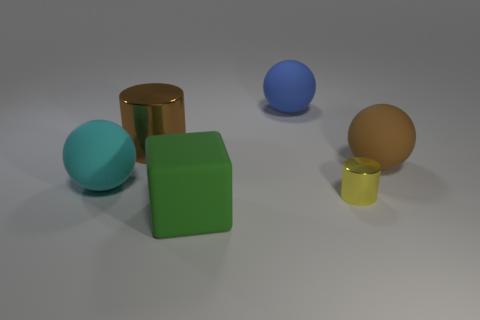What is the material of the big brown cylinder?
Your answer should be very brief. Metal. There is a large rubber thing right of the metallic cylinder in front of the brown sphere; what is its color?
Offer a terse response. Brown. Are there fewer large balls in front of the green cube than big rubber spheres right of the small cylinder?
Keep it short and to the point. Yes. Is the size of the blue ball the same as the rubber object in front of the cyan rubber ball?
Provide a short and direct response. Yes. What shape is the object that is in front of the brown rubber sphere and left of the large green object?
Give a very brief answer. Sphere. There is a yellow cylinder that is the same material as the brown cylinder; what is its size?
Provide a short and direct response. Small. How many large shiny cylinders are to the right of the blue thing behind the big brown cylinder?
Provide a short and direct response. 0. Do the large brown object that is in front of the big metallic thing and the small yellow cylinder have the same material?
Keep it short and to the point. No. How big is the metal thing to the left of the green thing on the right side of the large cyan thing?
Make the answer very short. Large. What is the size of the matte object that is behind the brown thing on the left side of the brown object right of the small yellow shiny object?
Give a very brief answer. Large. 